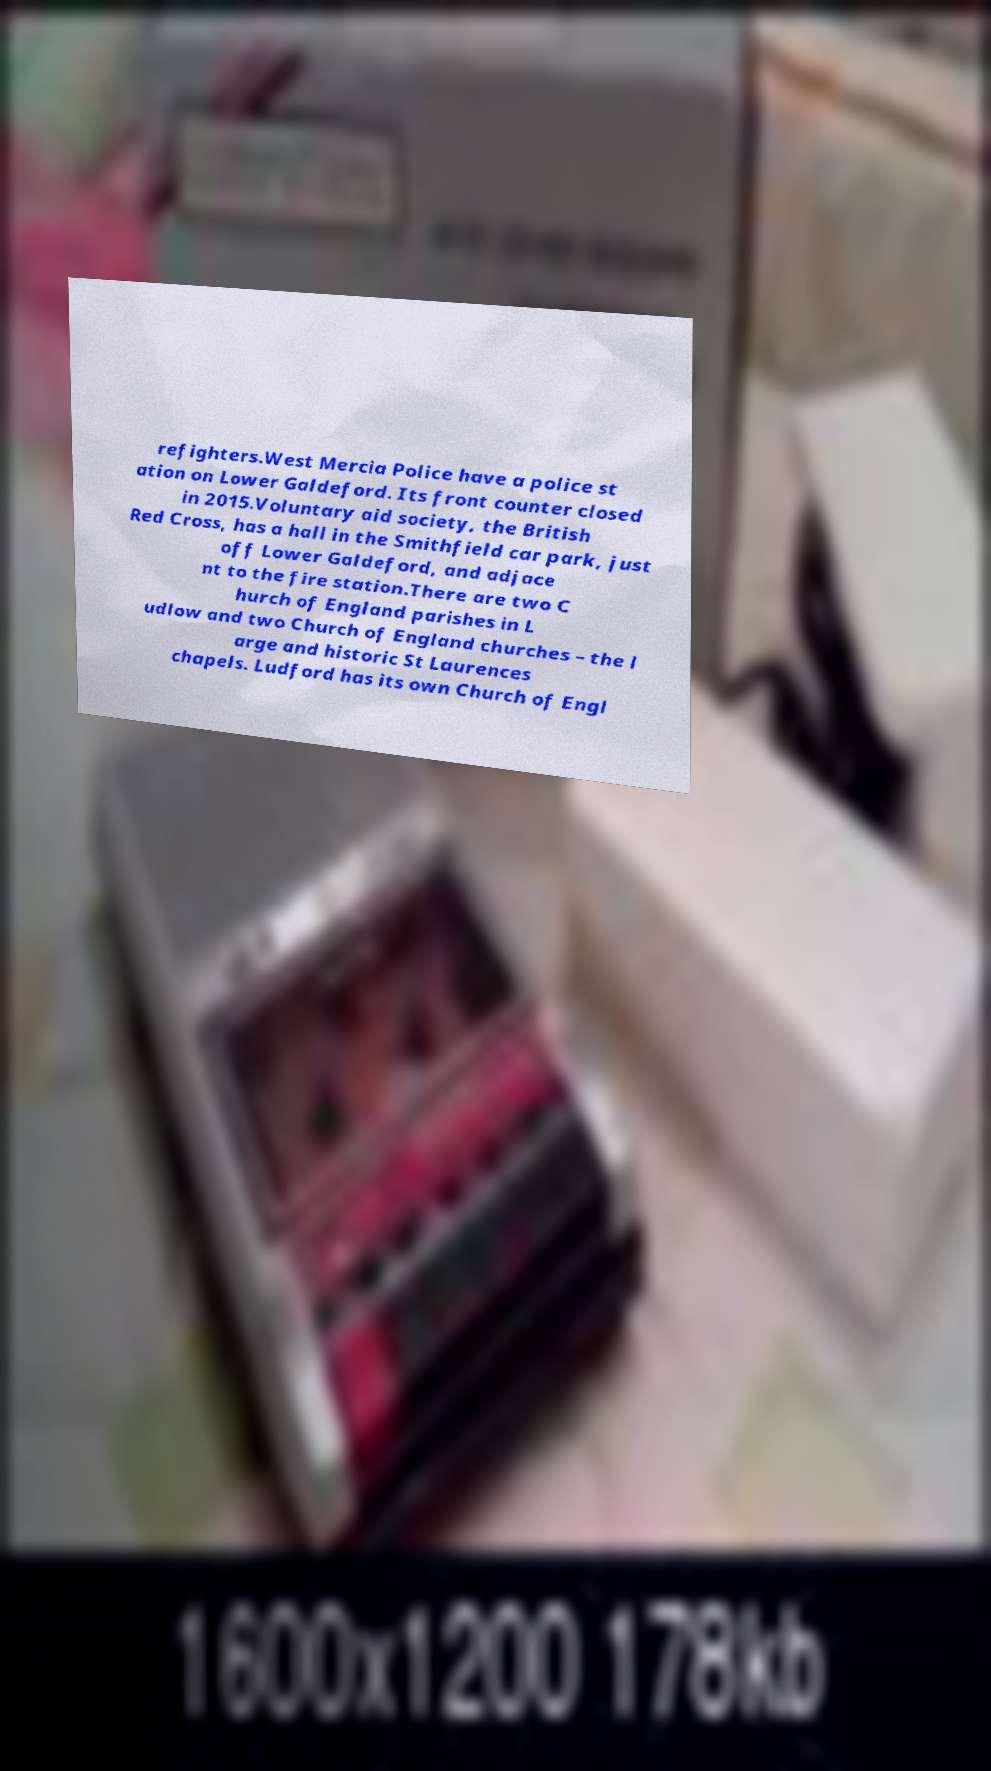What messages or text are displayed in this image? I need them in a readable, typed format. refighters.West Mercia Police have a police st ation on Lower Galdeford. Its front counter closed in 2015.Voluntary aid society, the British Red Cross, has a hall in the Smithfield car park, just off Lower Galdeford, and adjace nt to the fire station.There are two C hurch of England parishes in L udlow and two Church of England churches – the l arge and historic St Laurences chapels. Ludford has its own Church of Engl 